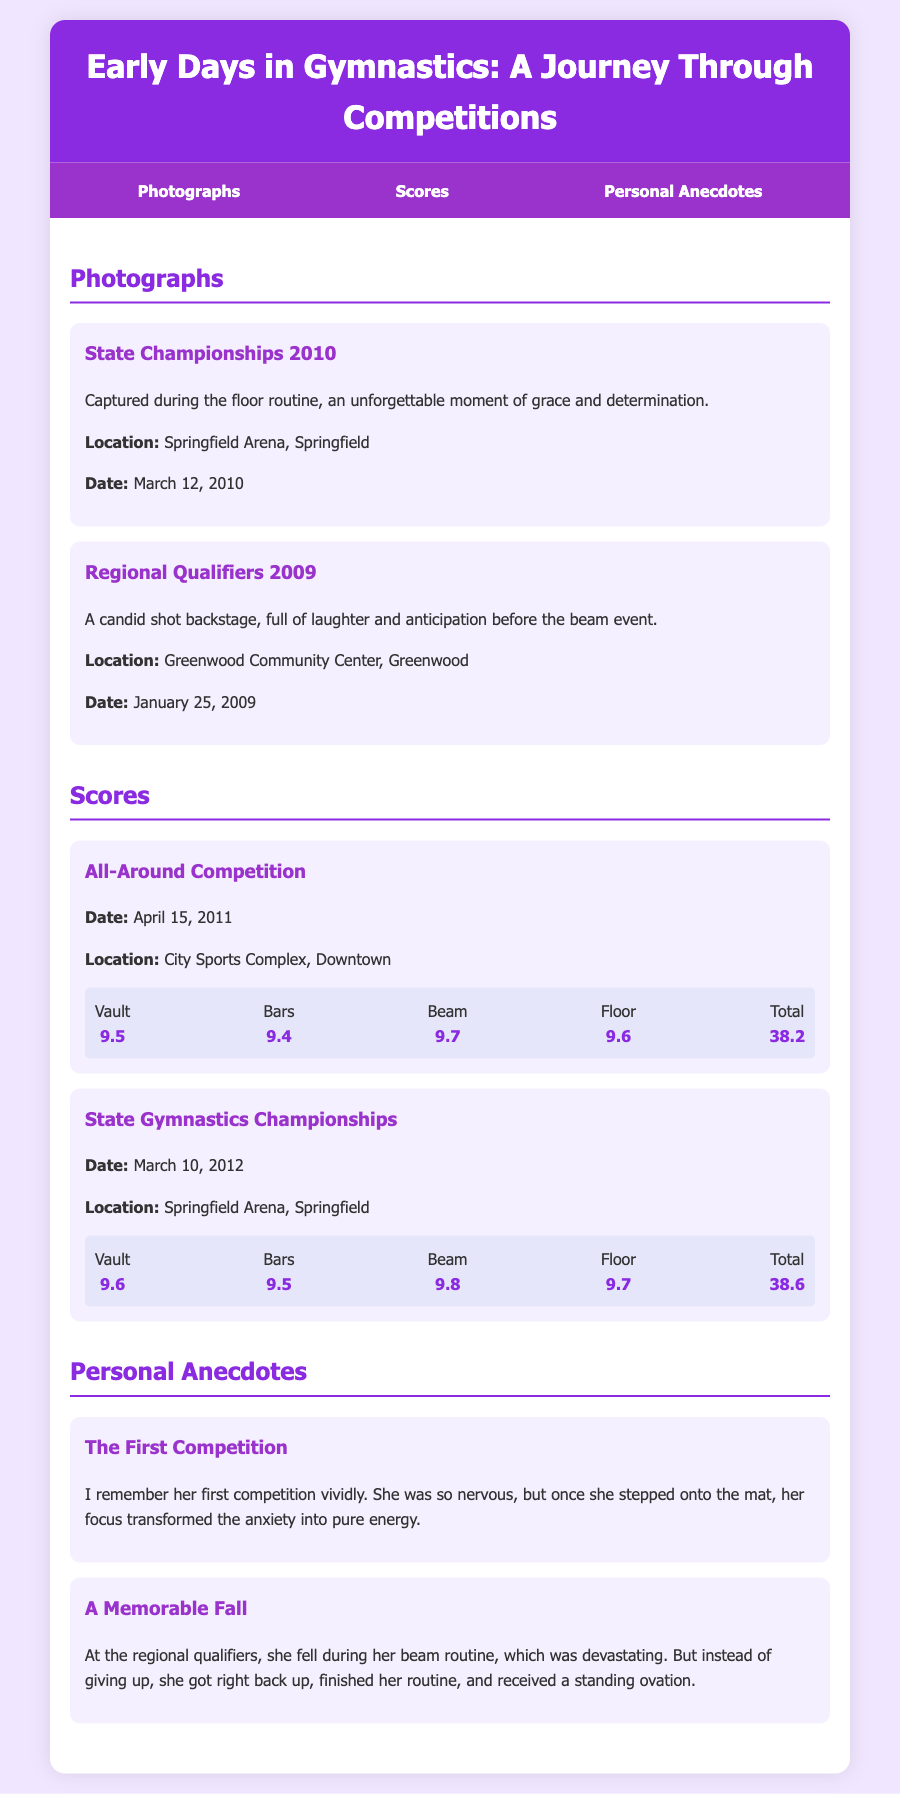What was the date of the State Championships? The date for the State Championships was mentioned under the photographs section.
Answer: March 12, 2010 What was her score on the beam during the All-Around Competition? The score for the beam in the All-Around Competition is listed in the scores section.
Answer: 9.7 Which event received the highest score in the State Gymnastics Championships? The highest score among the events in the State Gymnastics Championships is stated in the scores section.
Answer: Beam What did she do after falling during her routine? The anecdote explains her actions after the fall during the beam routine.
Answer: Finished her routine Where was the Regional Qualifiers held? The location of the Regional Qualifiers is specified under the photographs section.
Answer: Greenwood Community Center, Greenwood How many events are listed in the All-Around Competition scores? The total events in the All-Around Competition can be counted from the scores section.
Answer: Four What was the highest total score achieved in the document? The highest total score is noted in the scores section for the State Gymnastics Championships.
Answer: 38.6 What type of shot was captured before the beam event at the Regional Qualifiers? The type of shot is described in the context of the photograph from the Regional Qualifiers.
Answer: Candid shot 